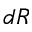Convert formula to latex. <formula><loc_0><loc_0><loc_500><loc_500>d R</formula> 